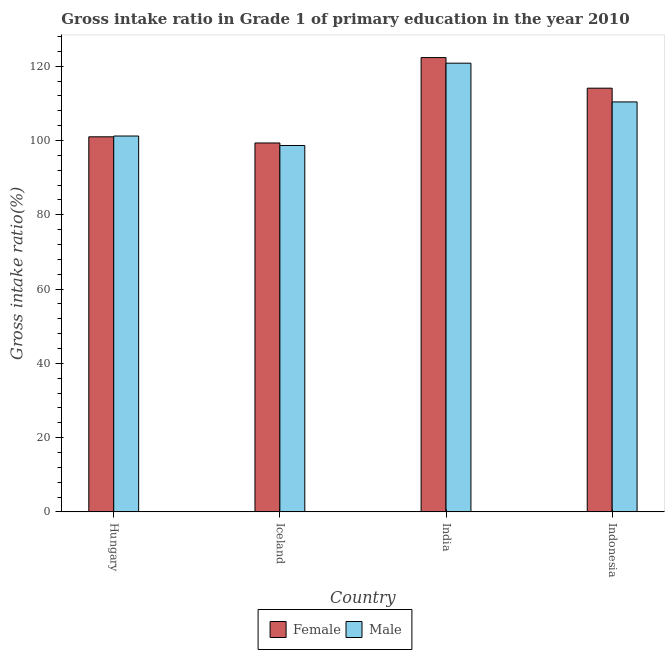How many different coloured bars are there?
Make the answer very short. 2. How many groups of bars are there?
Offer a terse response. 4. Are the number of bars on each tick of the X-axis equal?
Provide a succinct answer. Yes. How many bars are there on the 4th tick from the left?
Keep it short and to the point. 2. In how many cases, is the number of bars for a given country not equal to the number of legend labels?
Ensure brevity in your answer.  0. What is the gross intake ratio(male) in India?
Your answer should be very brief. 120.81. Across all countries, what is the maximum gross intake ratio(male)?
Keep it short and to the point. 120.81. Across all countries, what is the minimum gross intake ratio(female)?
Provide a short and direct response. 99.33. In which country was the gross intake ratio(male) minimum?
Keep it short and to the point. Iceland. What is the total gross intake ratio(male) in the graph?
Ensure brevity in your answer.  431.04. What is the difference between the gross intake ratio(female) in Iceland and that in Indonesia?
Offer a very short reply. -14.76. What is the difference between the gross intake ratio(female) in Indonesia and the gross intake ratio(male) in Iceland?
Your response must be concise. 15.43. What is the average gross intake ratio(female) per country?
Your answer should be very brief. 109.18. What is the difference between the gross intake ratio(male) and gross intake ratio(female) in India?
Provide a succinct answer. -1.51. In how many countries, is the gross intake ratio(male) greater than 24 %?
Keep it short and to the point. 4. What is the ratio of the gross intake ratio(female) in India to that in Indonesia?
Give a very brief answer. 1.07. Is the difference between the gross intake ratio(female) in India and Indonesia greater than the difference between the gross intake ratio(male) in India and Indonesia?
Your answer should be compact. No. What is the difference between the highest and the second highest gross intake ratio(female)?
Make the answer very short. 8.24. What is the difference between the highest and the lowest gross intake ratio(female)?
Make the answer very short. 22.99. What does the 1st bar from the right in Indonesia represents?
Your answer should be compact. Male. How many countries are there in the graph?
Your answer should be very brief. 4. Where does the legend appear in the graph?
Provide a succinct answer. Bottom center. How are the legend labels stacked?
Make the answer very short. Horizontal. What is the title of the graph?
Provide a succinct answer. Gross intake ratio in Grade 1 of primary education in the year 2010. Does "State government" appear as one of the legend labels in the graph?
Make the answer very short. No. What is the label or title of the Y-axis?
Your answer should be very brief. Gross intake ratio(%). What is the Gross intake ratio(%) of Female in Hungary?
Ensure brevity in your answer.  100.99. What is the Gross intake ratio(%) in Male in Hungary?
Provide a short and direct response. 101.2. What is the Gross intake ratio(%) of Female in Iceland?
Offer a terse response. 99.33. What is the Gross intake ratio(%) of Male in Iceland?
Make the answer very short. 98.65. What is the Gross intake ratio(%) in Female in India?
Provide a short and direct response. 122.32. What is the Gross intake ratio(%) of Male in India?
Provide a succinct answer. 120.81. What is the Gross intake ratio(%) in Female in Indonesia?
Provide a short and direct response. 114.08. What is the Gross intake ratio(%) of Male in Indonesia?
Your response must be concise. 110.38. Across all countries, what is the maximum Gross intake ratio(%) in Female?
Provide a succinct answer. 122.32. Across all countries, what is the maximum Gross intake ratio(%) of Male?
Ensure brevity in your answer.  120.81. Across all countries, what is the minimum Gross intake ratio(%) in Female?
Keep it short and to the point. 99.33. Across all countries, what is the minimum Gross intake ratio(%) in Male?
Give a very brief answer. 98.65. What is the total Gross intake ratio(%) in Female in the graph?
Keep it short and to the point. 436.72. What is the total Gross intake ratio(%) in Male in the graph?
Your answer should be compact. 431.04. What is the difference between the Gross intake ratio(%) in Female in Hungary and that in Iceland?
Provide a short and direct response. 1.66. What is the difference between the Gross intake ratio(%) in Male in Hungary and that in Iceland?
Provide a short and direct response. 2.55. What is the difference between the Gross intake ratio(%) in Female in Hungary and that in India?
Give a very brief answer. -21.33. What is the difference between the Gross intake ratio(%) of Male in Hungary and that in India?
Keep it short and to the point. -19.61. What is the difference between the Gross intake ratio(%) in Female in Hungary and that in Indonesia?
Ensure brevity in your answer.  -13.09. What is the difference between the Gross intake ratio(%) of Male in Hungary and that in Indonesia?
Offer a terse response. -9.18. What is the difference between the Gross intake ratio(%) in Female in Iceland and that in India?
Offer a very short reply. -22.99. What is the difference between the Gross intake ratio(%) of Male in Iceland and that in India?
Give a very brief answer. -22.16. What is the difference between the Gross intake ratio(%) of Female in Iceland and that in Indonesia?
Offer a very short reply. -14.76. What is the difference between the Gross intake ratio(%) in Male in Iceland and that in Indonesia?
Ensure brevity in your answer.  -11.73. What is the difference between the Gross intake ratio(%) of Female in India and that in Indonesia?
Provide a succinct answer. 8.24. What is the difference between the Gross intake ratio(%) of Male in India and that in Indonesia?
Give a very brief answer. 10.43. What is the difference between the Gross intake ratio(%) in Female in Hungary and the Gross intake ratio(%) in Male in Iceland?
Your answer should be very brief. 2.34. What is the difference between the Gross intake ratio(%) of Female in Hungary and the Gross intake ratio(%) of Male in India?
Provide a short and direct response. -19.82. What is the difference between the Gross intake ratio(%) of Female in Hungary and the Gross intake ratio(%) of Male in Indonesia?
Your answer should be compact. -9.39. What is the difference between the Gross intake ratio(%) in Female in Iceland and the Gross intake ratio(%) in Male in India?
Make the answer very short. -21.49. What is the difference between the Gross intake ratio(%) in Female in Iceland and the Gross intake ratio(%) in Male in Indonesia?
Your answer should be very brief. -11.06. What is the difference between the Gross intake ratio(%) in Female in India and the Gross intake ratio(%) in Male in Indonesia?
Provide a short and direct response. 11.94. What is the average Gross intake ratio(%) in Female per country?
Give a very brief answer. 109.18. What is the average Gross intake ratio(%) of Male per country?
Keep it short and to the point. 107.76. What is the difference between the Gross intake ratio(%) of Female and Gross intake ratio(%) of Male in Hungary?
Your answer should be very brief. -0.21. What is the difference between the Gross intake ratio(%) of Female and Gross intake ratio(%) of Male in Iceland?
Offer a terse response. 0.68. What is the difference between the Gross intake ratio(%) in Female and Gross intake ratio(%) in Male in India?
Your answer should be very brief. 1.51. What is the difference between the Gross intake ratio(%) of Female and Gross intake ratio(%) of Male in Indonesia?
Offer a very short reply. 3.7. What is the ratio of the Gross intake ratio(%) in Female in Hungary to that in Iceland?
Give a very brief answer. 1.02. What is the ratio of the Gross intake ratio(%) in Male in Hungary to that in Iceland?
Make the answer very short. 1.03. What is the ratio of the Gross intake ratio(%) in Female in Hungary to that in India?
Give a very brief answer. 0.83. What is the ratio of the Gross intake ratio(%) of Male in Hungary to that in India?
Your response must be concise. 0.84. What is the ratio of the Gross intake ratio(%) of Female in Hungary to that in Indonesia?
Your answer should be very brief. 0.89. What is the ratio of the Gross intake ratio(%) in Male in Hungary to that in Indonesia?
Give a very brief answer. 0.92. What is the ratio of the Gross intake ratio(%) in Female in Iceland to that in India?
Ensure brevity in your answer.  0.81. What is the ratio of the Gross intake ratio(%) of Male in Iceland to that in India?
Provide a short and direct response. 0.82. What is the ratio of the Gross intake ratio(%) in Female in Iceland to that in Indonesia?
Offer a very short reply. 0.87. What is the ratio of the Gross intake ratio(%) in Male in Iceland to that in Indonesia?
Your answer should be compact. 0.89. What is the ratio of the Gross intake ratio(%) of Female in India to that in Indonesia?
Your answer should be compact. 1.07. What is the ratio of the Gross intake ratio(%) of Male in India to that in Indonesia?
Offer a terse response. 1.09. What is the difference between the highest and the second highest Gross intake ratio(%) of Female?
Make the answer very short. 8.24. What is the difference between the highest and the second highest Gross intake ratio(%) of Male?
Make the answer very short. 10.43. What is the difference between the highest and the lowest Gross intake ratio(%) of Female?
Give a very brief answer. 22.99. What is the difference between the highest and the lowest Gross intake ratio(%) of Male?
Offer a very short reply. 22.16. 